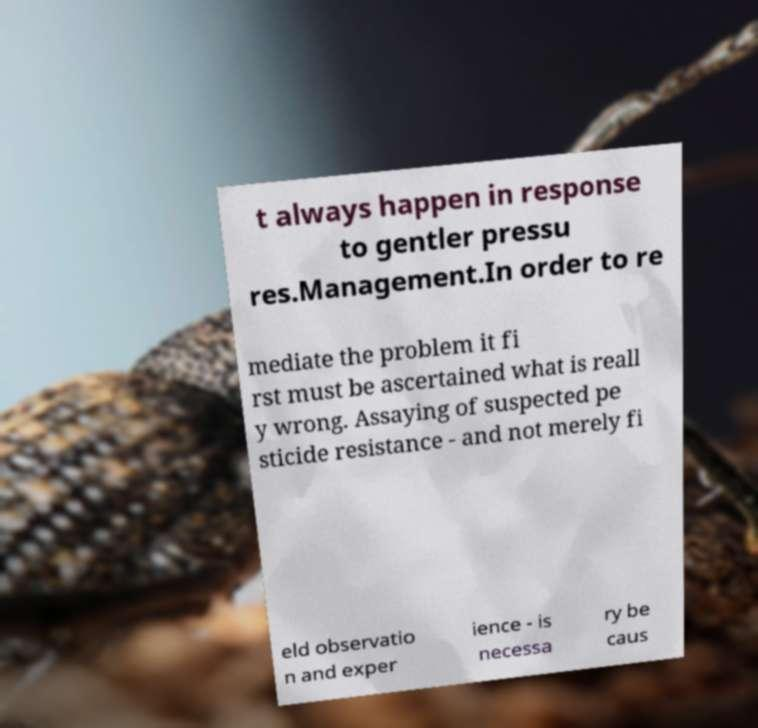Can you read and provide the text displayed in the image?This photo seems to have some interesting text. Can you extract and type it out for me? t always happen in response to gentler pressu res.Management.In order to re mediate the problem it fi rst must be ascertained what is reall y wrong. Assaying of suspected pe sticide resistance - and not merely fi eld observatio n and exper ience - is necessa ry be caus 